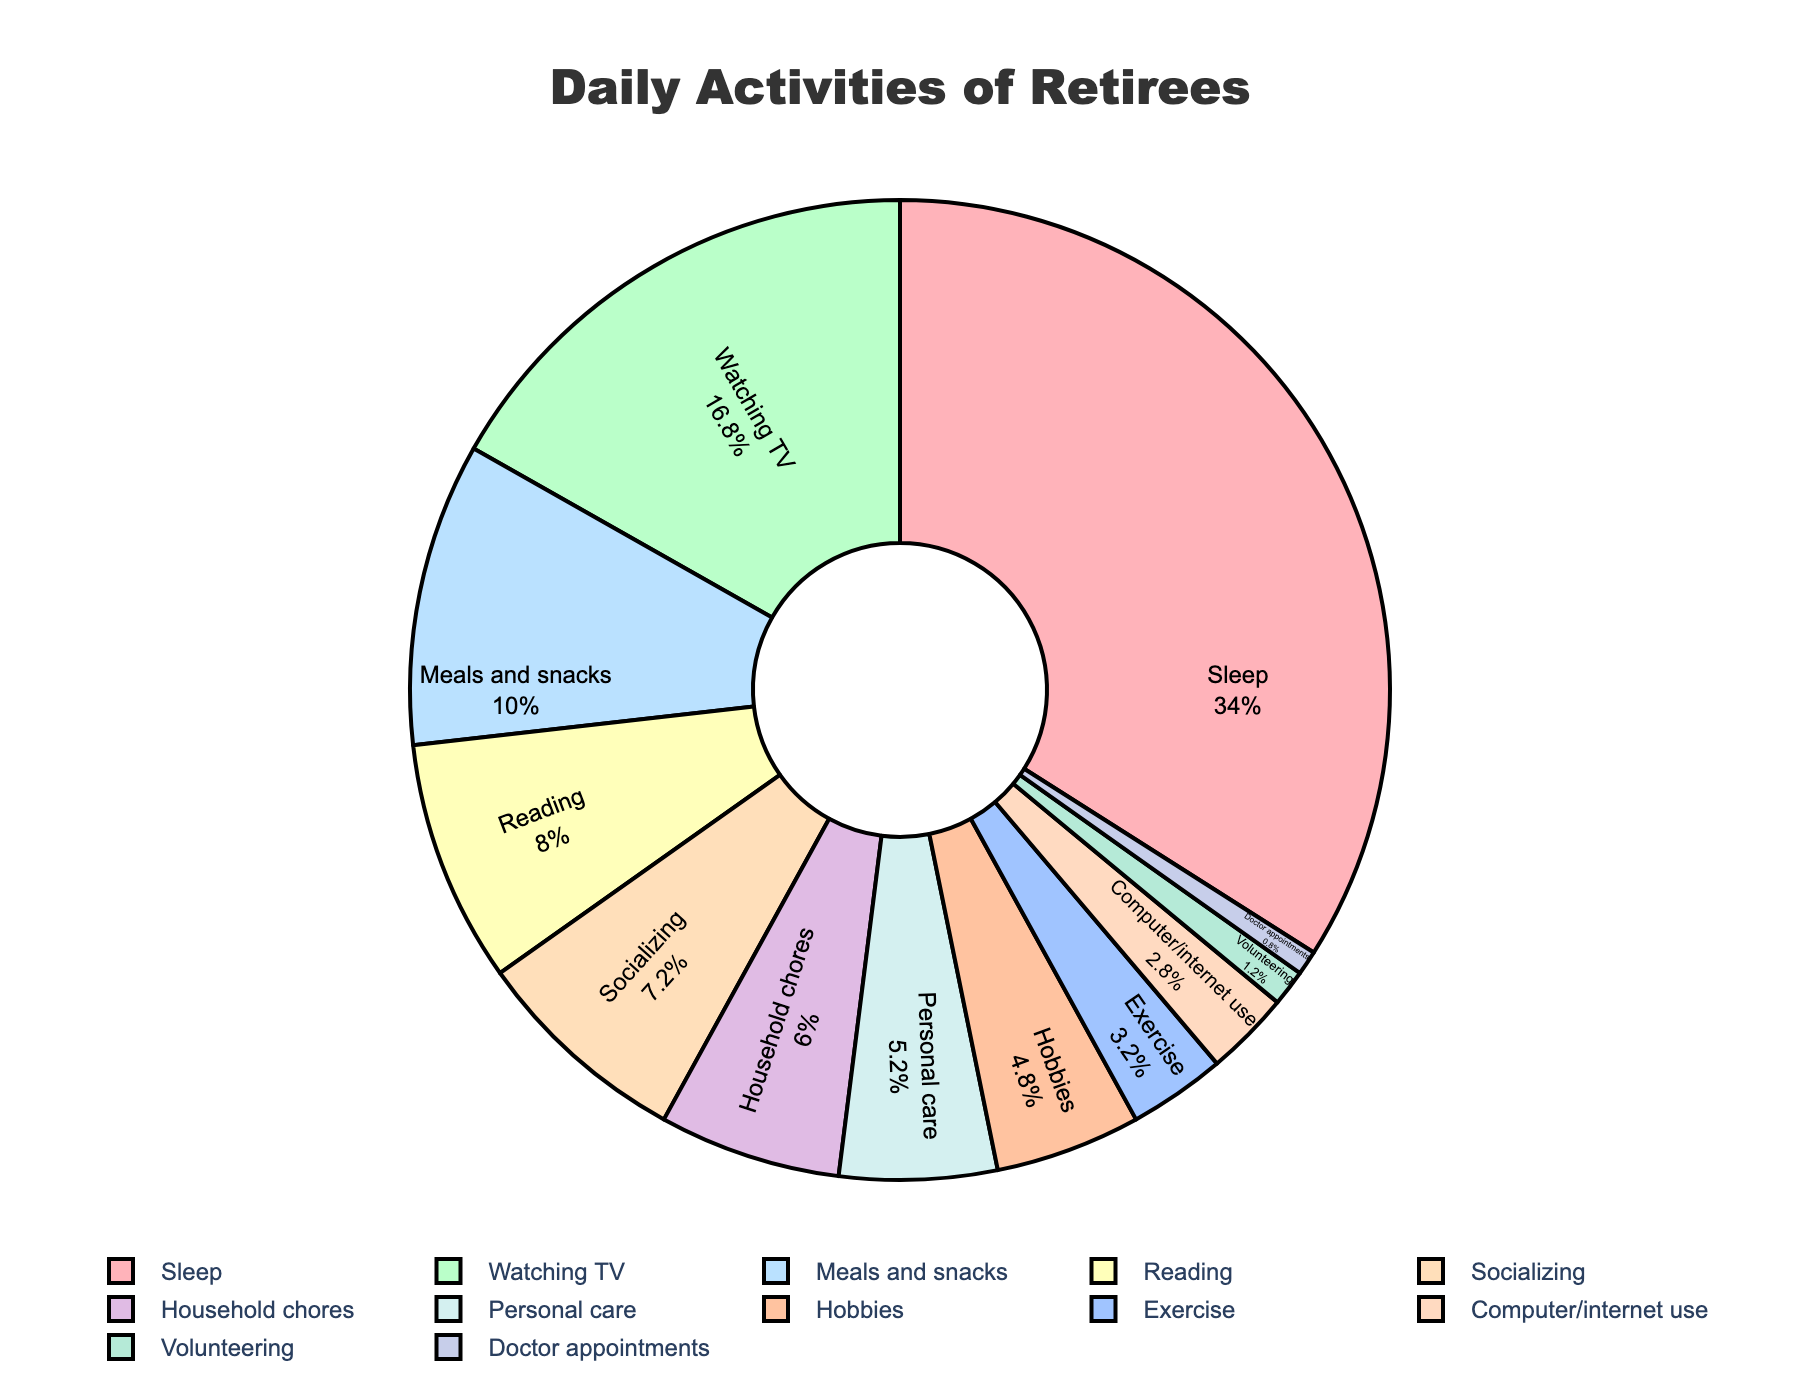What's the total amount of time spent on meals and snacks, socializing, and reading? Sum the hours spent on meals and snacks (2.5), socializing (1.8), and reading (2.0). The total is 2.5 + 1.8 + 2.0 = 6.3 hours.
Answer: 6.3 hours Which activity do retirees spend more time on: hobbies or exercise? Compare the hours spent on hobbies (1.2) and exercise (0.8). Retirees spend more time on hobbies (1.2 hours).
Answer: Hobbies What is the percentage of time spent on sleep out of the total daily hours? Total the hours for all activities: 8.5 + 4.2 + 2.5 + 2.0 + 1.8 + 1.5 + 1.3 + 1.2 + 0.8 + 0.7 + 0.3 + 0.2 = 25 hours. Calculate the percentage for sleep: (8.5 / 25) * 100 = 34%.
Answer: 34% Do retirees spend more time watching TV or on household chores and personal care combined? Add the hours for household chores (1.5) and personal care (1.3) to get 1.5 + 1.3 = 2.8 hours. Compare this with the time spent watching TV (4.2 hours). Retirees spend more time watching TV (4.2 hours).
Answer: Watching TV What activity accounts for the smallest portion of a retiree's day? Look for the activity with the smallest number of hours. Doctor appointments account for 0.2 hours, which is the smallest.
Answer: Doctor appointments How much more time is spent on sleeping compared to reading? Subtract the hours spent on reading (2.0) from the hours spent on sleeping (8.5). The difference is 8.5 - 2.0 = 6.5 hours.
Answer: 6.5 hours What is the sum of hours spent on hobbies, exercise, and computer/internet use? Sum the hours spent on hobbies (1.2), exercise (0.8), and computer/internet use (0.7). The total is 1.2 + 0.8 + 0.7 = 2.7 hours.
Answer: 2.7 hours What is the combined percentage of time spent on meals, socializing, and personal care? Combine the hours: 2.5 (meals and snacks) + 1.8 (socializing) + 1.3 (personal care) = 5.6 hours. Calculate the percentage for these activities: (5.6 / 25) * 100 = 22.4%.
Answer: 22.4% Which activity's segment is colored blue in the pie chart? Identify the activity associated with the blue color by examining the segments and legend. According to the color scheme, computer/internet use is colored blue.
Answer: Computer/internet use 